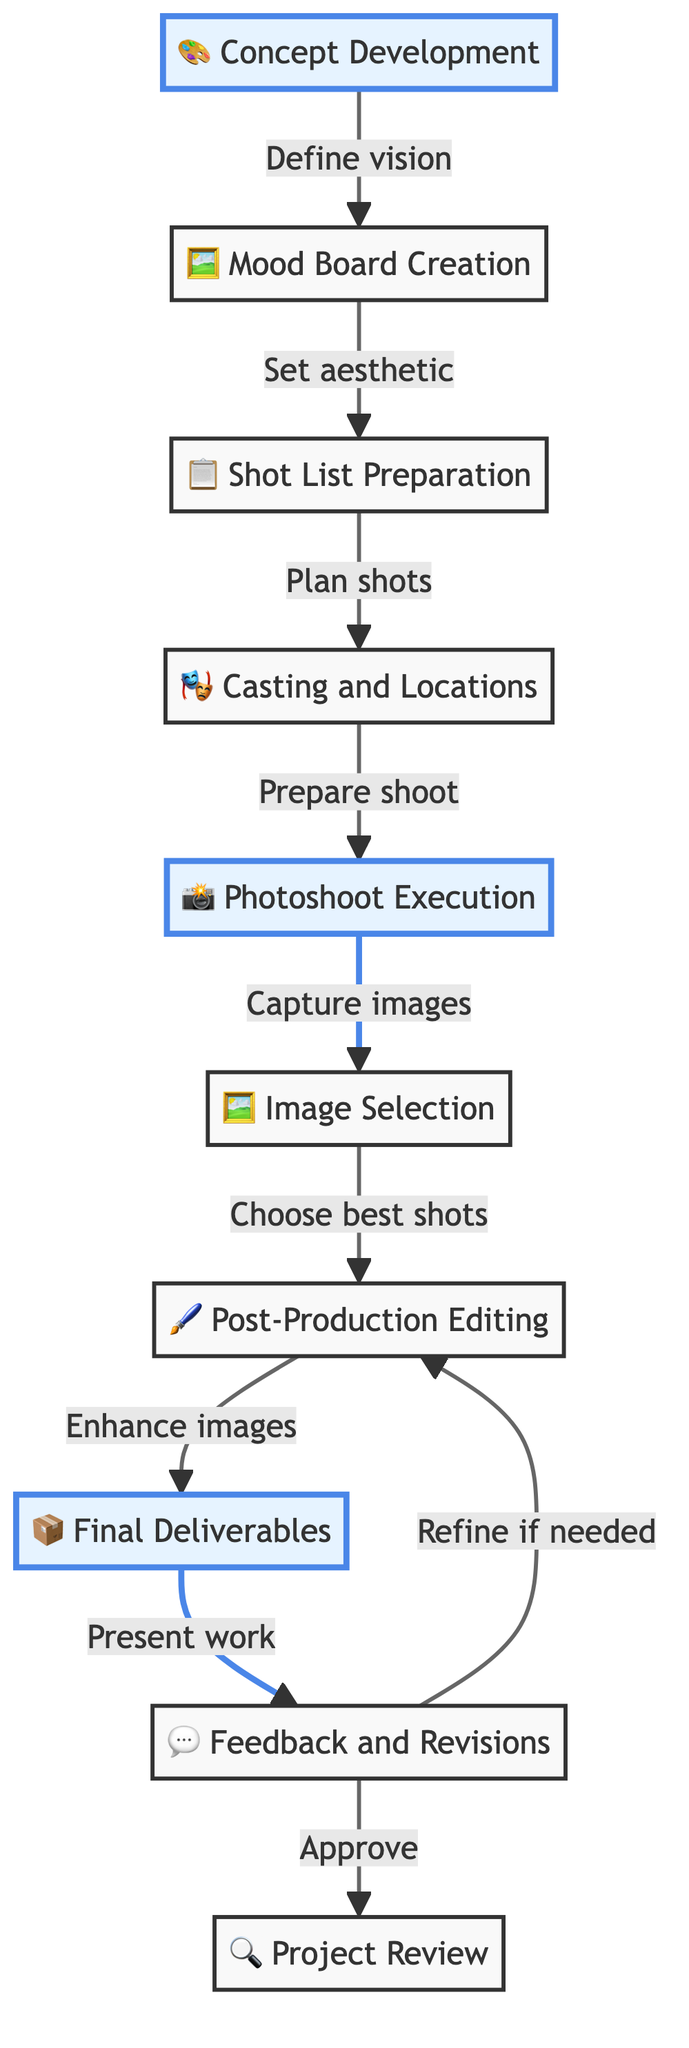What is the first step in the photography project workflow? The diagram begins with the "Concept Development" step, which is the first node. This establishes the initial stage of the workflow.
Answer: Concept Development How many nodes are there in the diagram? The diagram includes 10 distinct nodes, representing various stages of the photography project workflow.
Answer: 10 What do you do after "Image Selection"? After "Image Selection," the workflow moves to "Post-Production Editing," which is the next step according to the connections in the diagram.
Answer: Post-Production Editing Which step involves obtaining feedback? The step that involves obtaining feedback is "Feedback and Revisions." This is explicitly stated in the workflow as sharing work with stakeholders for their input.
Answer: Feedback and Revisions What is the relationship between "Casting and Locations" and "Photoshoot Execution"? "Casting and Locations" directly leads to "Photoshoot Execution," indicating that preparing for models and locations is a prerequisite to conducting the actual photoshoot.
Answer: Prepare shoot What happens if feedback is provided in the "Feedback and Revisions" step? If feedback is received, the workflow indicates that it may require revisiting the "Post-Production Editing" step, suggesting potential revisions as necessary.
Answer: Refining if needed What is the final step in the photography project workflow? The final step is "Project Review," which evaluates the project's outcomes and lessons learned after all deliverables and revisions have been completed.
Answer: Project Review How does "Mood Board Creation" relate to "Shot List Preparation"? The connection indicates that the outcome of "Mood Board Creation," which sets the aesthetic, directly informs the "Shot List Preparation," demonstrating that aesthetics guide the planning of specific shots.
Answer: Sets aesthetic Which steps are highlighted in the diagram? The highlighted steps in the diagram are "Concept Development," "Photoshoot Execution," and "Final Deliverables," indicating their significant status in the workflow.
Answer: Concept Development, Photoshoot Execution, Final Deliverables 